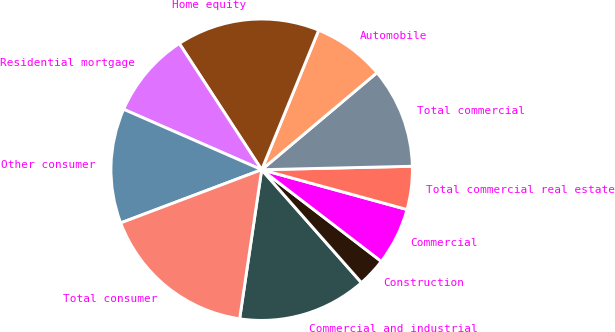Convert chart to OTSL. <chart><loc_0><loc_0><loc_500><loc_500><pie_chart><fcel>Commercial and industrial<fcel>Construction<fcel>Commercial<fcel>Total commercial real estate<fcel>Total commercial<fcel>Automobile<fcel>Home equity<fcel>Residential mortgage<fcel>Other consumer<fcel>Total consumer<nl><fcel>13.85%<fcel>3.08%<fcel>6.15%<fcel>4.62%<fcel>10.77%<fcel>7.69%<fcel>15.38%<fcel>9.23%<fcel>12.31%<fcel>16.92%<nl></chart> 